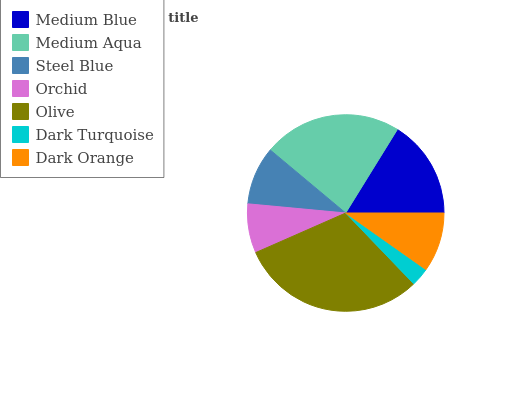Is Dark Turquoise the minimum?
Answer yes or no. Yes. Is Olive the maximum?
Answer yes or no. Yes. Is Medium Aqua the minimum?
Answer yes or no. No. Is Medium Aqua the maximum?
Answer yes or no. No. Is Medium Aqua greater than Medium Blue?
Answer yes or no. Yes. Is Medium Blue less than Medium Aqua?
Answer yes or no. Yes. Is Medium Blue greater than Medium Aqua?
Answer yes or no. No. Is Medium Aqua less than Medium Blue?
Answer yes or no. No. Is Dark Orange the high median?
Answer yes or no. Yes. Is Dark Orange the low median?
Answer yes or no. Yes. Is Olive the high median?
Answer yes or no. No. Is Dark Turquoise the low median?
Answer yes or no. No. 